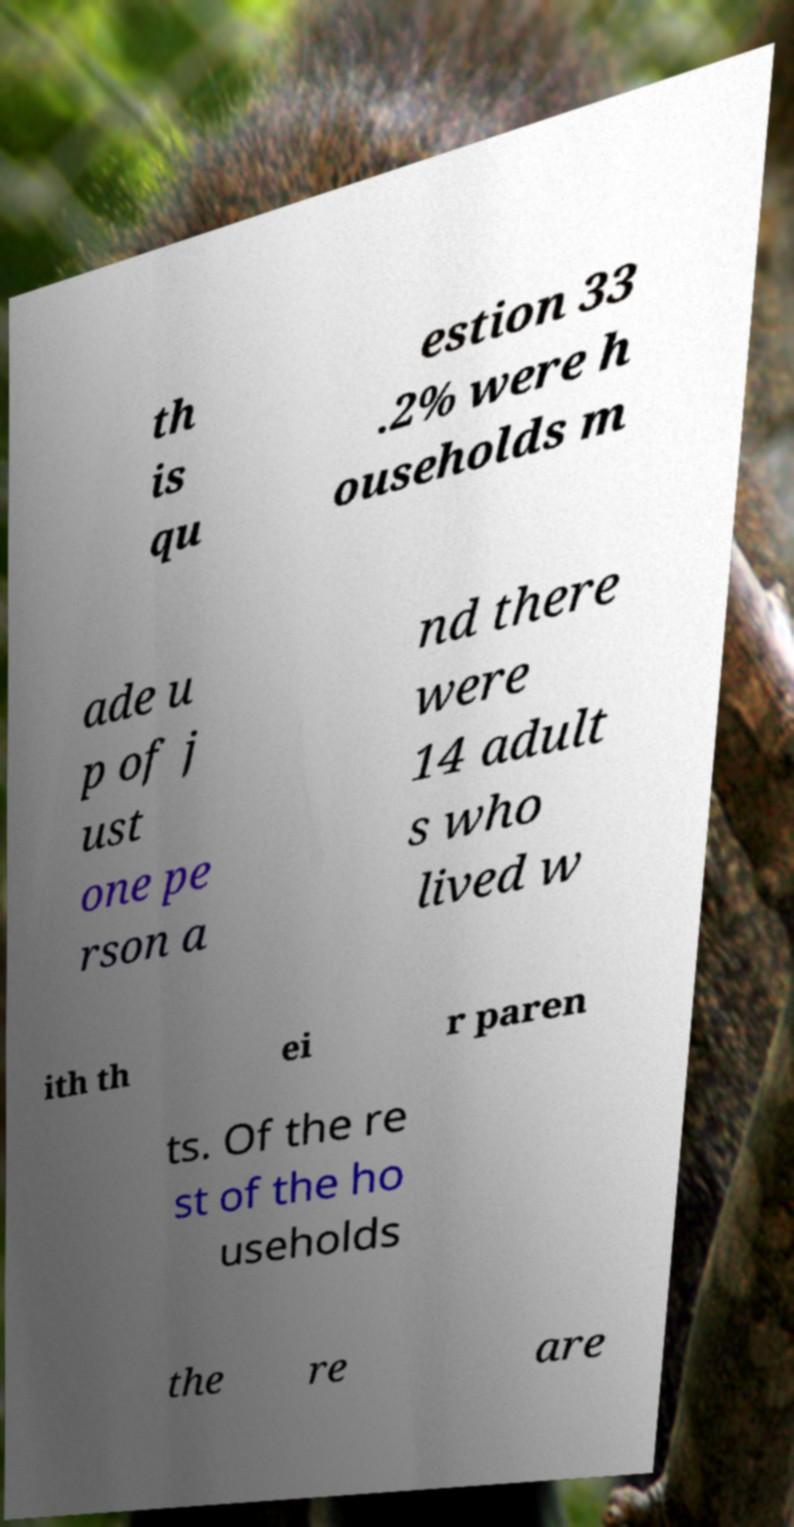Could you assist in decoding the text presented in this image and type it out clearly? th is qu estion 33 .2% were h ouseholds m ade u p of j ust one pe rson a nd there were 14 adult s who lived w ith th ei r paren ts. Of the re st of the ho useholds the re are 